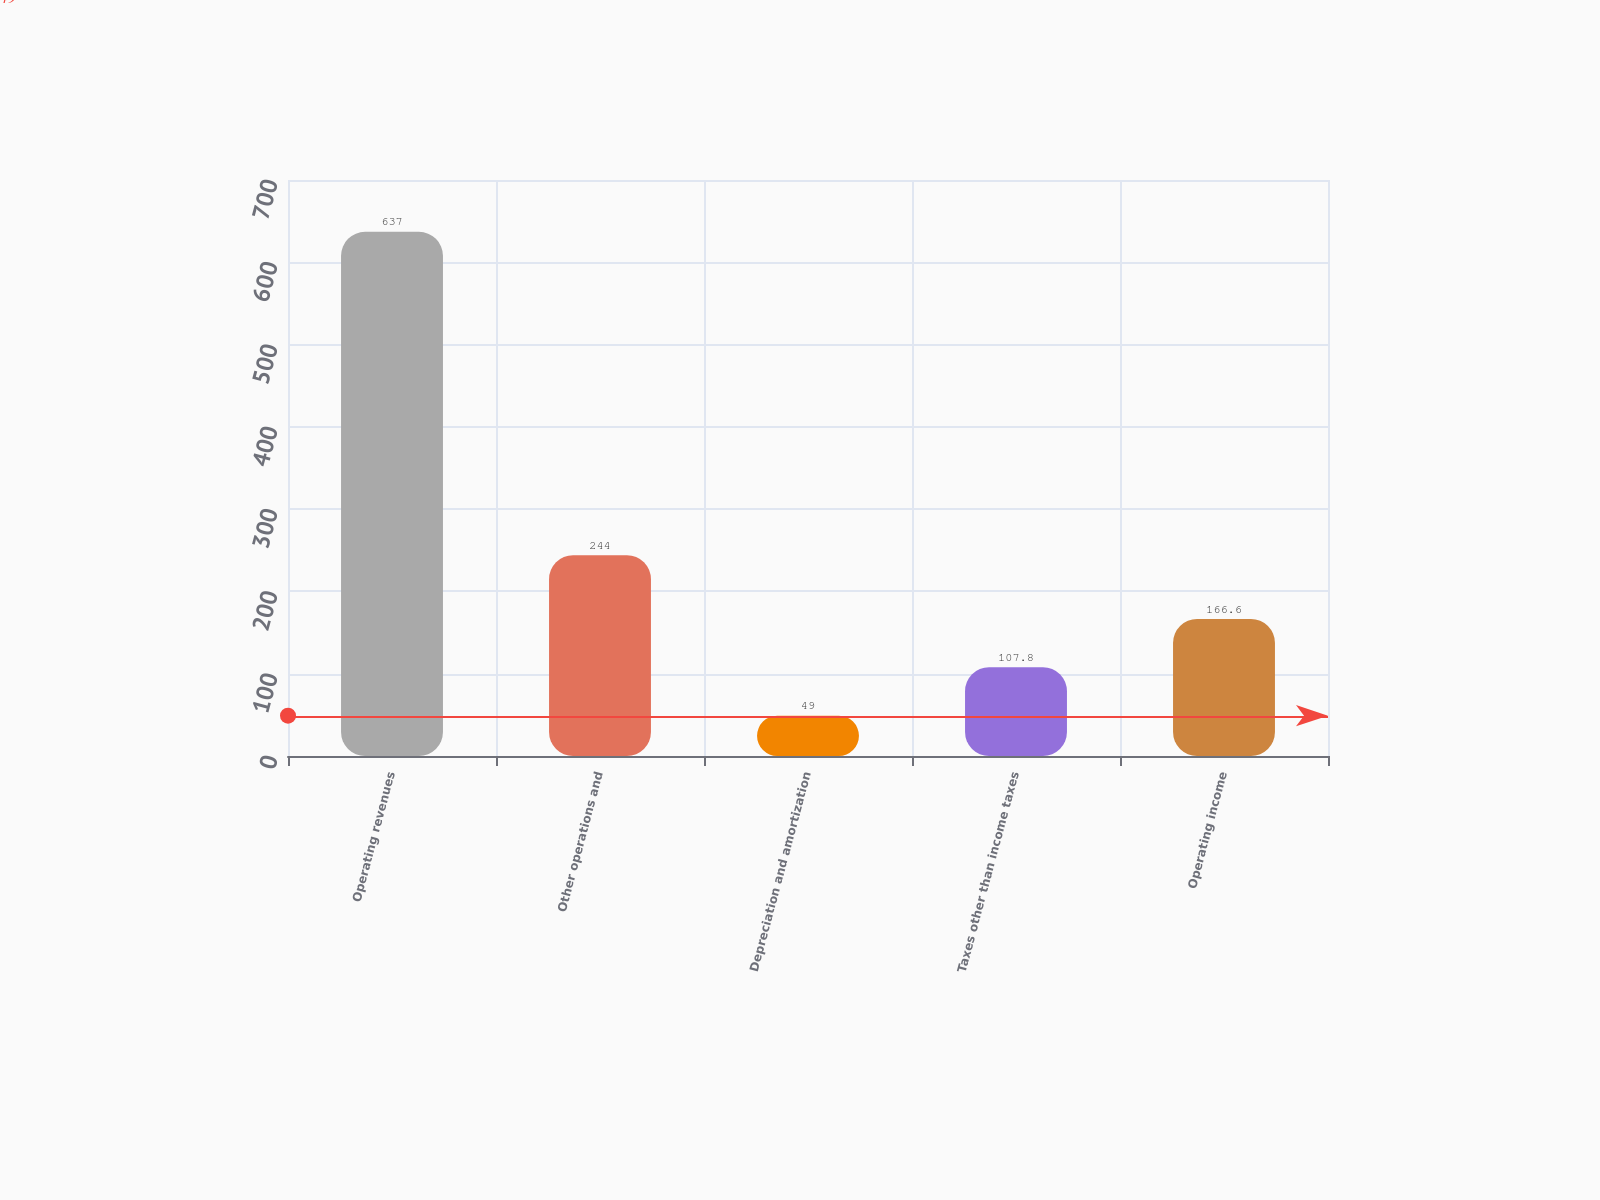Convert chart. <chart><loc_0><loc_0><loc_500><loc_500><bar_chart><fcel>Operating revenues<fcel>Other operations and<fcel>Depreciation and amortization<fcel>Taxes other than income taxes<fcel>Operating income<nl><fcel>637<fcel>244<fcel>49<fcel>107.8<fcel>166.6<nl></chart> 